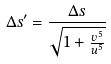Convert formula to latex. <formula><loc_0><loc_0><loc_500><loc_500>\Delta s ^ { \prime } = \frac { \Delta s } { \sqrt { 1 + \frac { v ^ { 5 } } { u ^ { 5 } } } }</formula> 